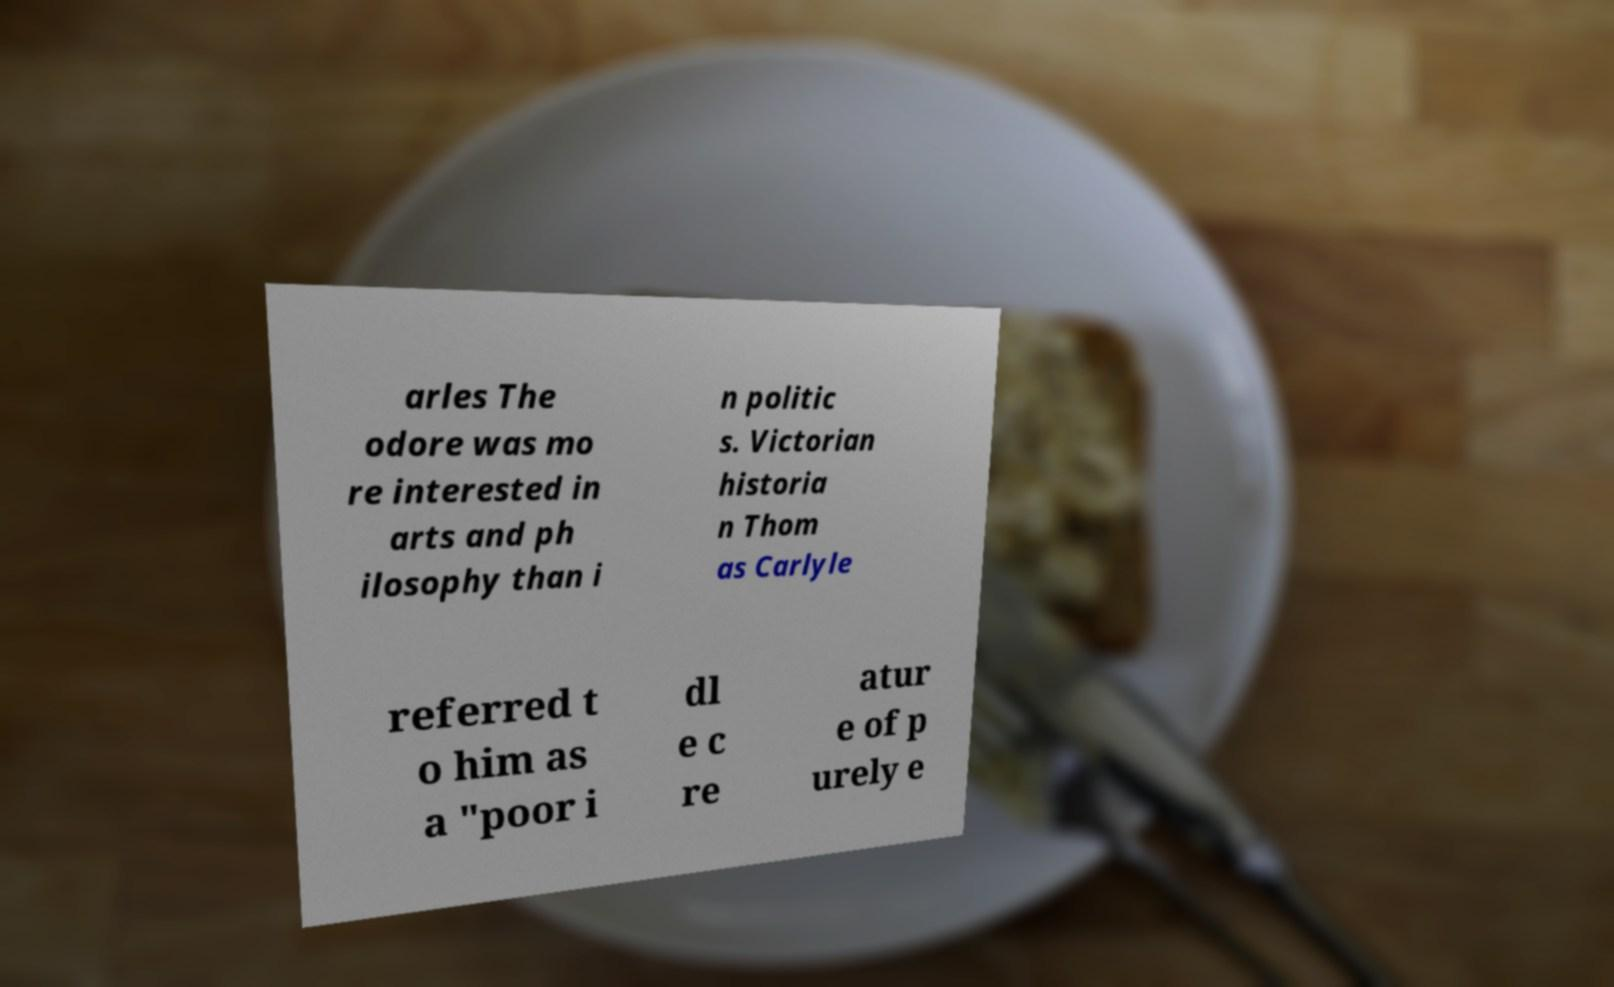I need the written content from this picture converted into text. Can you do that? arles The odore was mo re interested in arts and ph ilosophy than i n politic s. Victorian historia n Thom as Carlyle referred t o him as a "poor i dl e c re atur e of p urely e 